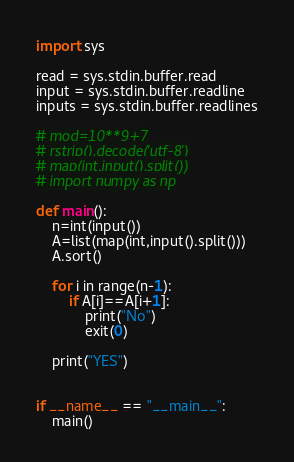Convert code to text. <code><loc_0><loc_0><loc_500><loc_500><_Python_>import sys

read = sys.stdin.buffer.read
input = sys.stdin.buffer.readline
inputs = sys.stdin.buffer.readlines

# mod=10**9+7
# rstrip().decode('utf-8')
# map(int,input().split())
# import numpy as np

def main():
	n=int(input())
	A=list(map(int,input().split()))
	A.sort()
	
	for i in range(n-1):
		if A[i]==A[i+1]:
			print("No")
			exit(0)
	
	print("YES")
	
	
if __name__ == "__main__":
	main()
</code> 